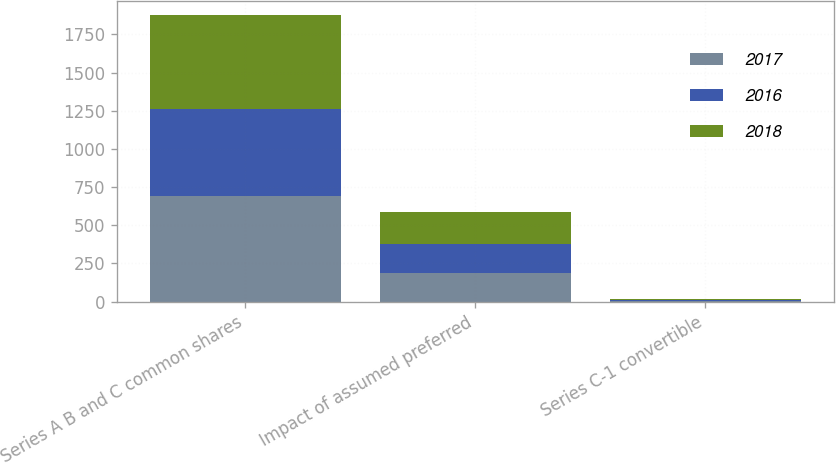<chart> <loc_0><loc_0><loc_500><loc_500><stacked_bar_chart><ecel><fcel>Series A B and C common shares<fcel>Impact of assumed preferred<fcel>Series C-1 convertible<nl><fcel>2017<fcel>688<fcel>187<fcel>6<nl><fcel>2016<fcel>576<fcel>192<fcel>6<nl><fcel>2018<fcel>610<fcel>206<fcel>7<nl></chart> 